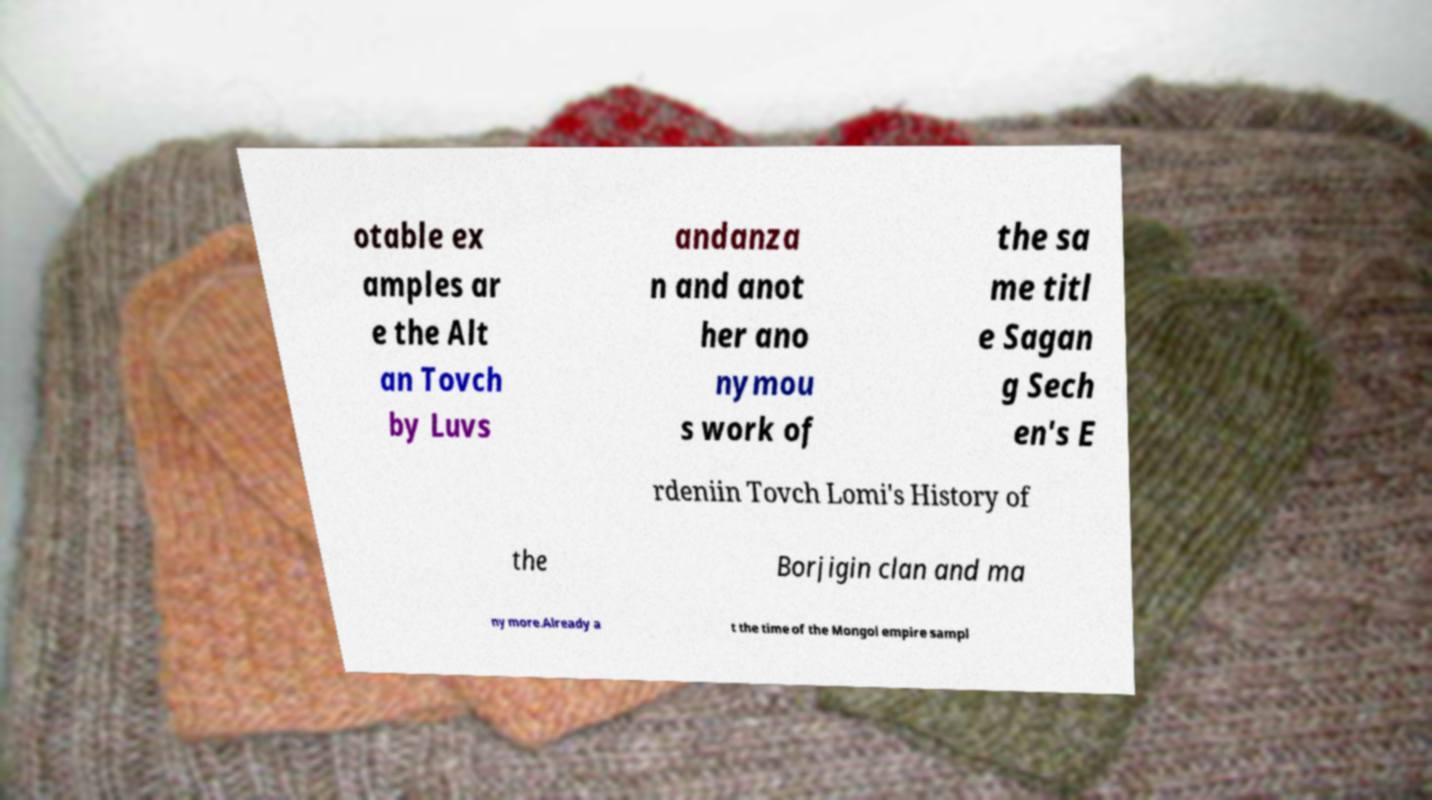I need the written content from this picture converted into text. Can you do that? otable ex amples ar e the Alt an Tovch by Luvs andanza n and anot her ano nymou s work of the sa me titl e Sagan g Sech en's E rdeniin Tovch Lomi's History of the Borjigin clan and ma ny more.Already a t the time of the Mongol empire sampl 